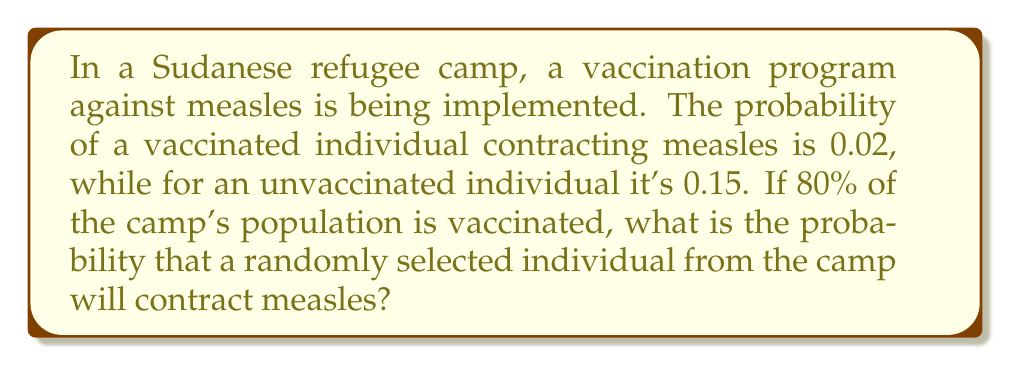Give your solution to this math problem. Let's approach this step-by-step using the law of total probability:

1) Define events:
   V: Individual is vaccinated
   M: Individual contracts measles

2) Given probabilities:
   P(V) = 0.80 (80% are vaccinated)
   P(M|V) = 0.02 (probability of contracting measles if vaccinated)
   P(M|not V) = 0.15 (probability of contracting measles if not vaccinated)

3) We want to find P(M), the probability of a random individual contracting measles.

4) Using the law of total probability:
   $$P(M) = P(M|V) \cdot P(V) + P(M|\text{not }V) \cdot P(\text{not }V)$$

5) We know P(V) = 0.80, so P(not V) = 1 - 0.80 = 0.20

6) Substituting the values:
   $$P(M) = 0.02 \cdot 0.80 + 0.15 \cdot 0.20$$

7) Calculating:
   $$P(M) = 0.016 + 0.030 = 0.046$$

Therefore, the probability that a randomly selected individual from the camp will contract measles is 0.046 or 4.6%.
Answer: 0.046 